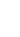<code> <loc_0><loc_0><loc_500><loc_500><_JavaScript_>
</code> 